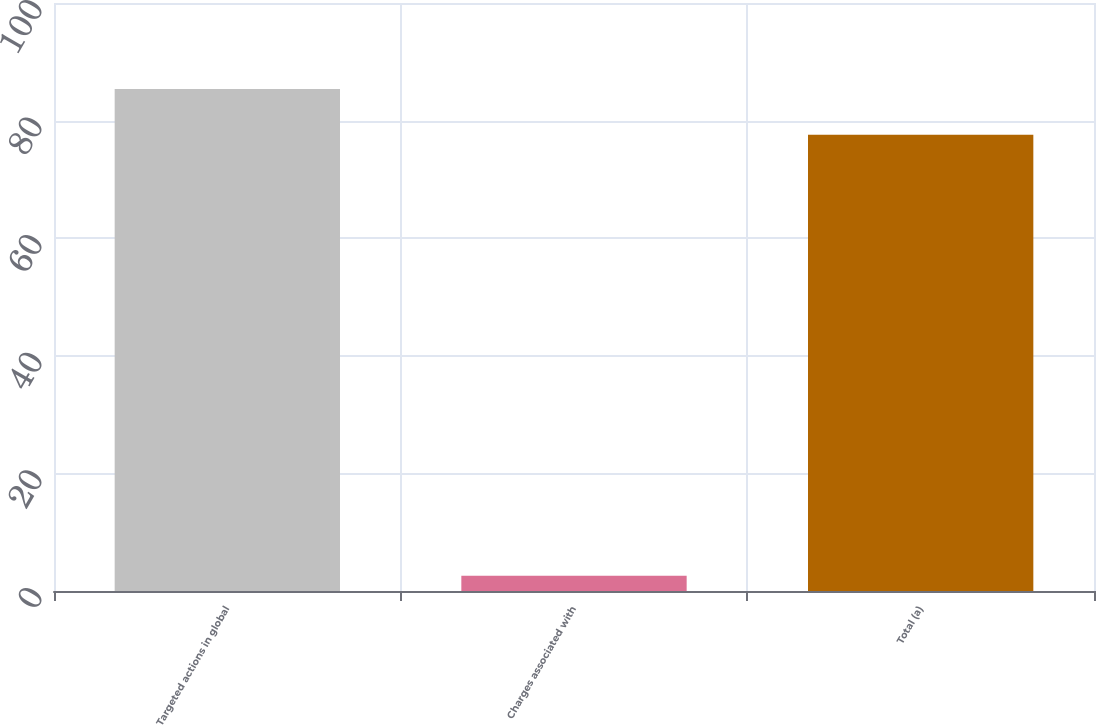Convert chart to OTSL. <chart><loc_0><loc_0><loc_500><loc_500><bar_chart><fcel>Targeted actions in global<fcel>Charges associated with<fcel>Total (a)<nl><fcel>85.36<fcel>2.6<fcel>77.6<nl></chart> 